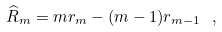Convert formula to latex. <formula><loc_0><loc_0><loc_500><loc_500>\widehat { R } _ { m } = m r _ { m } - ( m - 1 ) r _ { m - 1 } \ ,</formula> 